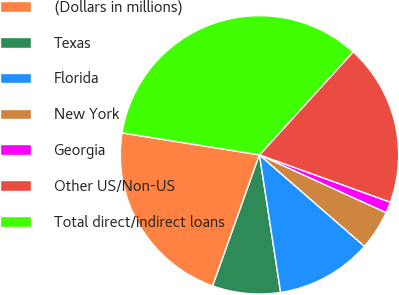Convert chart. <chart><loc_0><loc_0><loc_500><loc_500><pie_chart><fcel>(Dollars in millions)<fcel>Texas<fcel>Florida<fcel>New York<fcel>Georgia<fcel>Other US/Non-US<fcel>Total direct/indirect loans<nl><fcel>22.07%<fcel>7.88%<fcel>11.17%<fcel>4.59%<fcel>1.29%<fcel>18.78%<fcel>34.22%<nl></chart> 